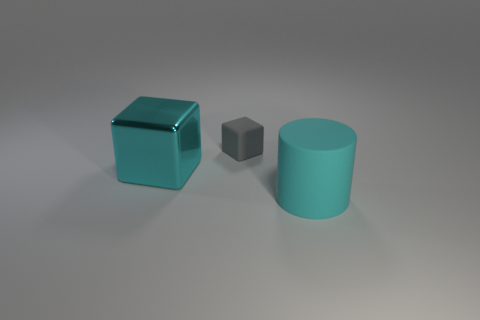What is the shape of the large object that is left of the small gray matte block?
Keep it short and to the point. Cube. How many things are both behind the big rubber cylinder and in front of the gray object?
Give a very brief answer. 1. What size is the other thing that is the same shape as the shiny thing?
Your answer should be compact. Small. What number of big blocks have the same material as the large cyan cylinder?
Ensure brevity in your answer.  0. Is the number of large cylinders on the right side of the small gray cube less than the number of tiny matte things?
Your answer should be compact. No. How many big cyan rubber objects are there?
Offer a very short reply. 1. How many other cubes have the same color as the big shiny block?
Your answer should be very brief. 0. Is the tiny rubber thing the same shape as the cyan metallic thing?
Your answer should be compact. Yes. What is the size of the cyan thing left of the large cyan thing that is on the right side of the cyan cube?
Offer a terse response. Large. Are there any cyan shiny cylinders that have the same size as the rubber cylinder?
Ensure brevity in your answer.  No. 